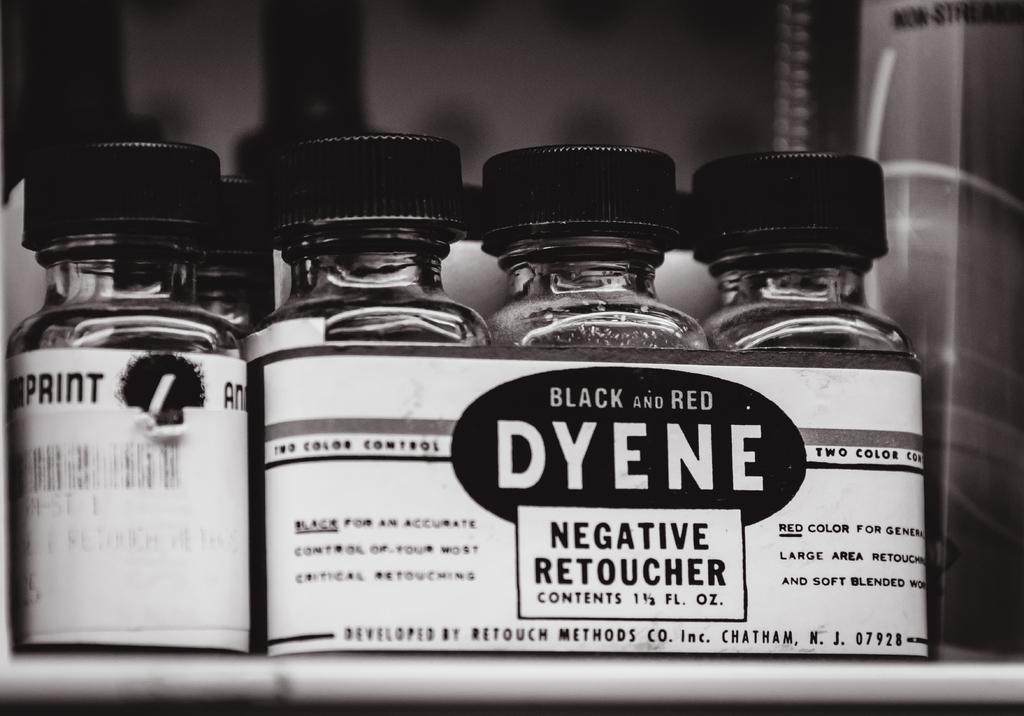<image>
Describe the image concisely. Bottles of Dyene negative retoucher sit on a shelf. 